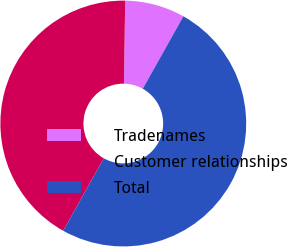<chart> <loc_0><loc_0><loc_500><loc_500><pie_chart><fcel>Tradenames<fcel>Customer relationships<fcel>Total<nl><fcel>7.88%<fcel>42.12%<fcel>50.0%<nl></chart> 